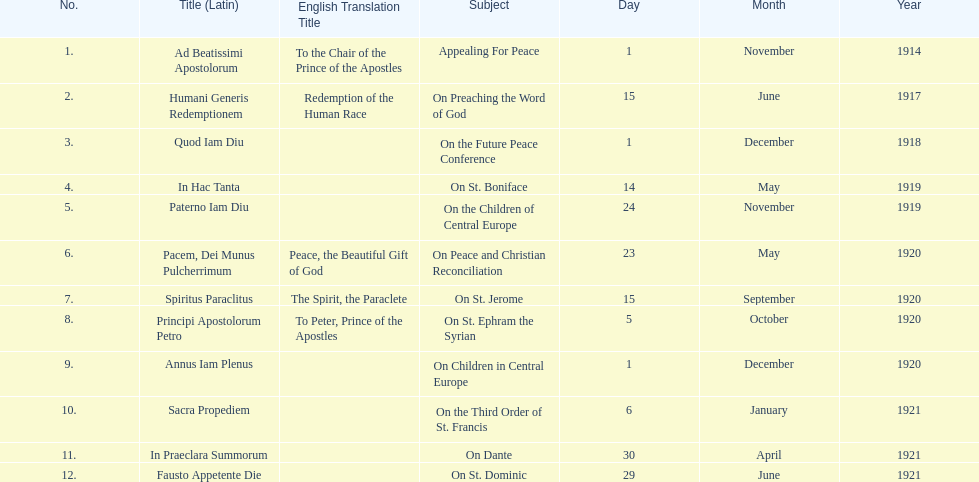After 1 december 1918 when was the next encyclical? 14 May 1919. 